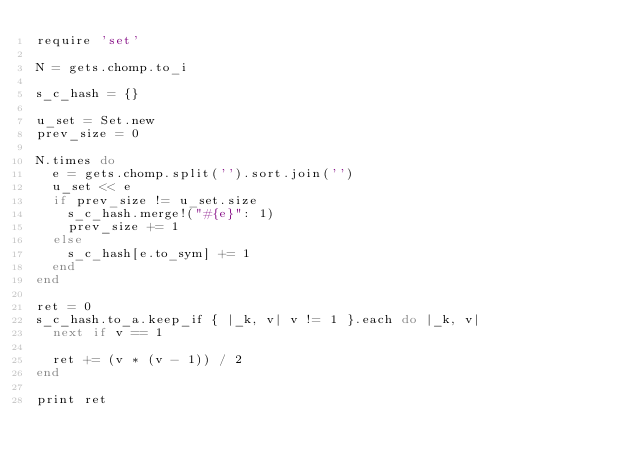Convert code to text. <code><loc_0><loc_0><loc_500><loc_500><_Ruby_>require 'set'

N = gets.chomp.to_i

s_c_hash = {}

u_set = Set.new
prev_size = 0

N.times do
  e = gets.chomp.split('').sort.join('')
  u_set << e
  if prev_size != u_set.size
    s_c_hash.merge!("#{e}": 1)
    prev_size += 1
  else
    s_c_hash[e.to_sym] += 1
  end
end

ret = 0
s_c_hash.to_a.keep_if { |_k, v| v != 1 }.each do |_k, v|
  next if v == 1

  ret += (v * (v - 1)) / 2
end

print ret
</code> 